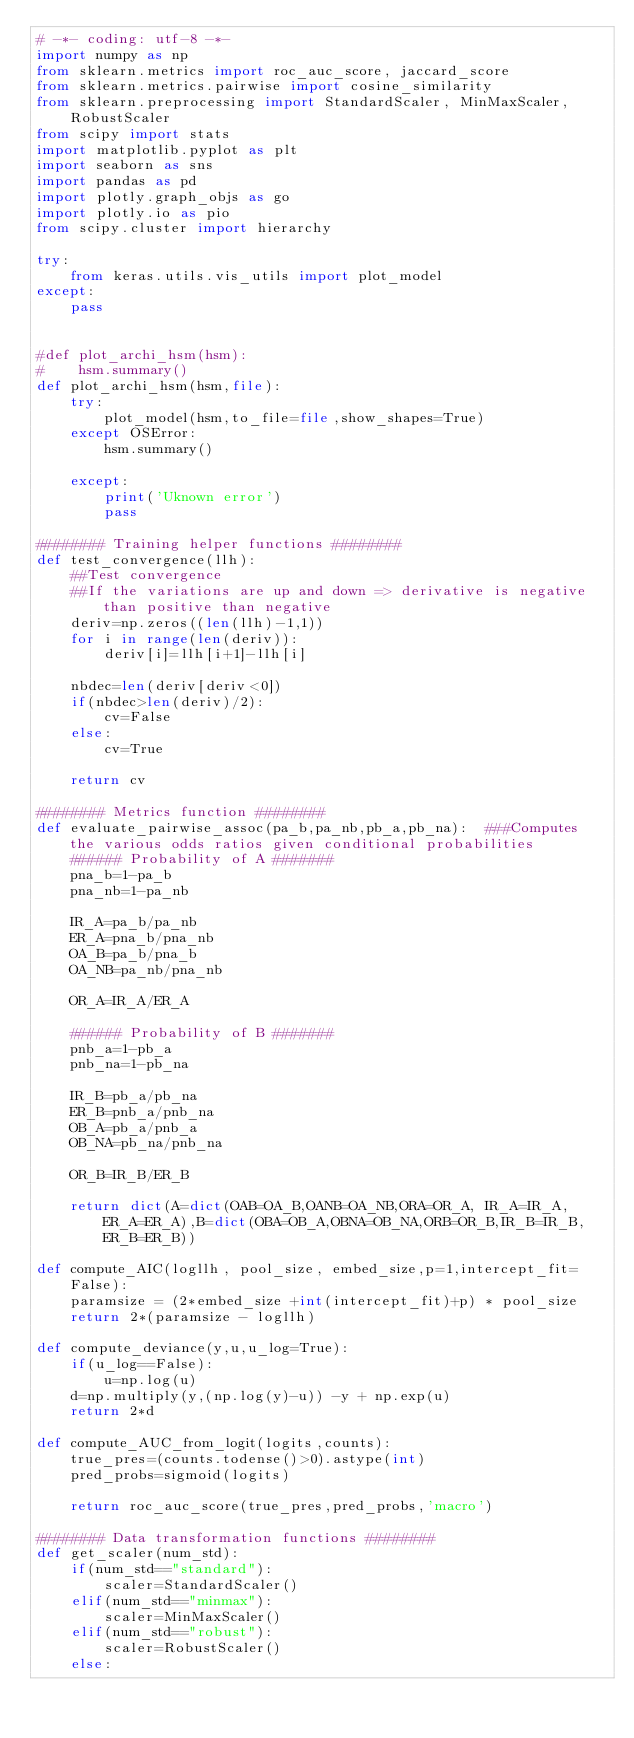Convert code to text. <code><loc_0><loc_0><loc_500><loc_500><_Python_># -*- coding: utf-8 -*-
import numpy as np
from sklearn.metrics import roc_auc_score, jaccard_score
from sklearn.metrics.pairwise import cosine_similarity
from sklearn.preprocessing import StandardScaler, MinMaxScaler, RobustScaler
from scipy import stats
import matplotlib.pyplot as plt
import seaborn as sns
import pandas as pd
import plotly.graph_objs as go
import plotly.io as pio
from scipy.cluster import hierarchy

try:
    from keras.utils.vis_utils import plot_model
except:
    pass


#def plot_archi_hsm(hsm):
#    hsm.summary()
def plot_archi_hsm(hsm,file):
    try:
        plot_model(hsm,to_file=file,show_shapes=True)
    except OSError:
        hsm.summary()
        
    except:
        print('Uknown error')
        pass

######## Training helper functions ########
def test_convergence(llh):
    ##Test convergence
    ##If the variations are up and down => derivative is negative than positive than negative
    deriv=np.zeros((len(llh)-1,1))
    for i in range(len(deriv)):
        deriv[i]=llh[i+1]-llh[i]
    
    nbdec=len(deriv[deriv<0])
    if(nbdec>len(deriv)/2):
        cv=False  
    else:
        cv=True
    
    return cv

######## Metrics function ########
def evaluate_pairwise_assoc(pa_b,pa_nb,pb_a,pb_na):  ###Computes the various odds ratios given conditional probabilities
    ###### Probability of A ####### 
    pna_b=1-pa_b
    pna_nb=1-pa_nb
    
    IR_A=pa_b/pa_nb
    ER_A=pna_b/pna_nb
    OA_B=pa_b/pna_b
    OA_NB=pa_nb/pna_nb
    
    OR_A=IR_A/ER_A
    
    ###### Probability of B #######     
    pnb_a=1-pb_a
    pnb_na=1-pb_na
    
    IR_B=pb_a/pb_na
    ER_B=pnb_a/pnb_na
    OB_A=pb_a/pnb_a
    OB_NA=pb_na/pnb_na
    
    OR_B=IR_B/ER_B
    
    return dict(A=dict(OAB=OA_B,OANB=OA_NB,ORA=OR_A, IR_A=IR_A, ER_A=ER_A),B=dict(OBA=OB_A,OBNA=OB_NA,ORB=OR_B,IR_B=IR_B, ER_B=ER_B))

def compute_AIC(logllh, pool_size, embed_size,p=1,intercept_fit=False):
    paramsize = (2*embed_size +int(intercept_fit)+p) * pool_size
    return 2*(paramsize - logllh)

def compute_deviance(y,u,u_log=True):
    if(u_log==False):
        u=np.log(u)
    d=np.multiply(y,(np.log(y)-u)) -y + np.exp(u)
    return 2*d

def compute_AUC_from_logit(logits,counts):
    true_pres=(counts.todense()>0).astype(int)
    pred_probs=sigmoid(logits)
    
    return roc_auc_score(true_pres,pred_probs,'macro')

######## Data transformation functions ######## 
def get_scaler(num_std):
    if(num_std=="standard"):
        scaler=StandardScaler()
    elif(num_std=="minmax"):
        scaler=MinMaxScaler()
    elif(num_std=="robust"):
        scaler=RobustScaler()
    else:</code> 